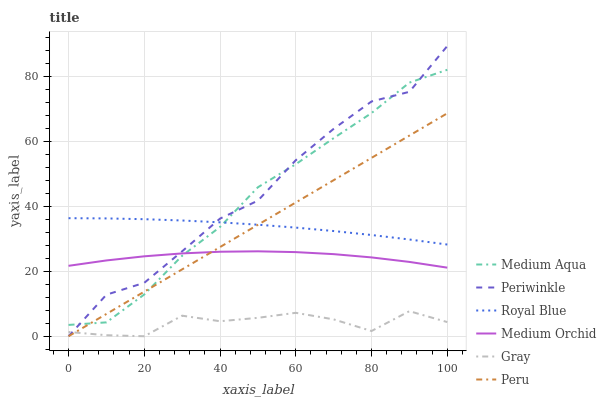Does Gray have the minimum area under the curve?
Answer yes or no. Yes. Does Periwinkle have the maximum area under the curve?
Answer yes or no. Yes. Does Medium Orchid have the minimum area under the curve?
Answer yes or no. No. Does Medium Orchid have the maximum area under the curve?
Answer yes or no. No. Is Peru the smoothest?
Answer yes or no. Yes. Is Periwinkle the roughest?
Answer yes or no. Yes. Is Medium Orchid the smoothest?
Answer yes or no. No. Is Medium Orchid the roughest?
Answer yes or no. No. Does Gray have the lowest value?
Answer yes or no. Yes. Does Medium Orchid have the lowest value?
Answer yes or no. No. Does Periwinkle have the highest value?
Answer yes or no. Yes. Does Medium Orchid have the highest value?
Answer yes or no. No. Is Gray less than Medium Aqua?
Answer yes or no. Yes. Is Medium Aqua greater than Gray?
Answer yes or no. Yes. Does Gray intersect Peru?
Answer yes or no. Yes. Is Gray less than Peru?
Answer yes or no. No. Is Gray greater than Peru?
Answer yes or no. No. Does Gray intersect Medium Aqua?
Answer yes or no. No. 